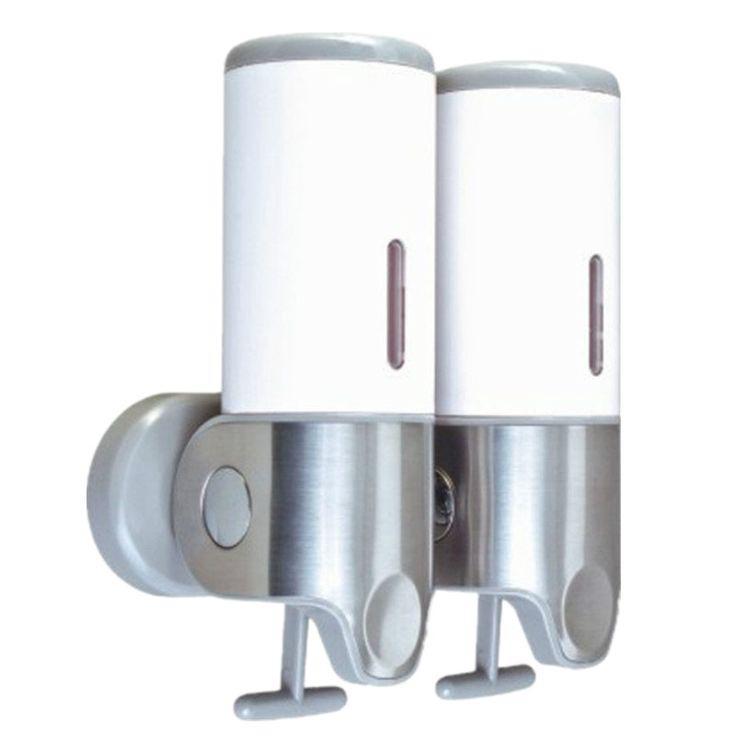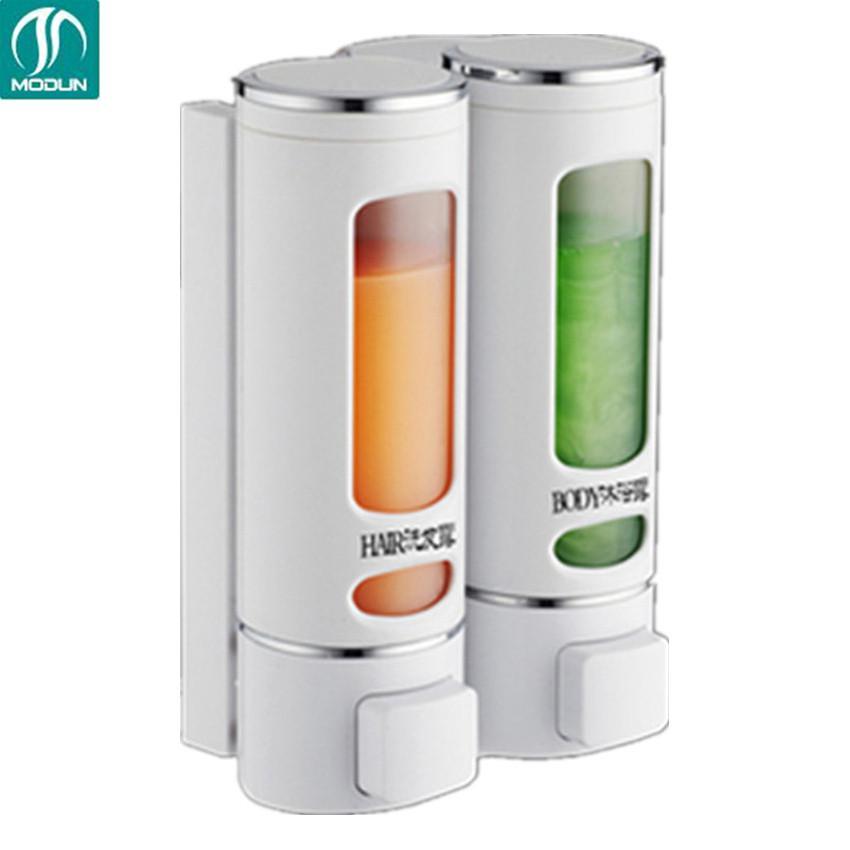The first image is the image on the left, the second image is the image on the right. Considering the images on both sides, is "At least one of the images shows a dual wall dispenser." valid? Answer yes or no. Yes. 